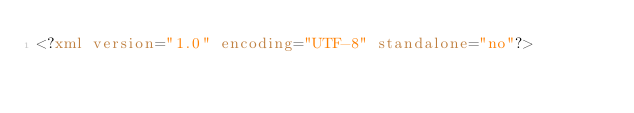<code> <loc_0><loc_0><loc_500><loc_500><_XML_><?xml version="1.0" encoding="UTF-8" standalone="no"?></code> 